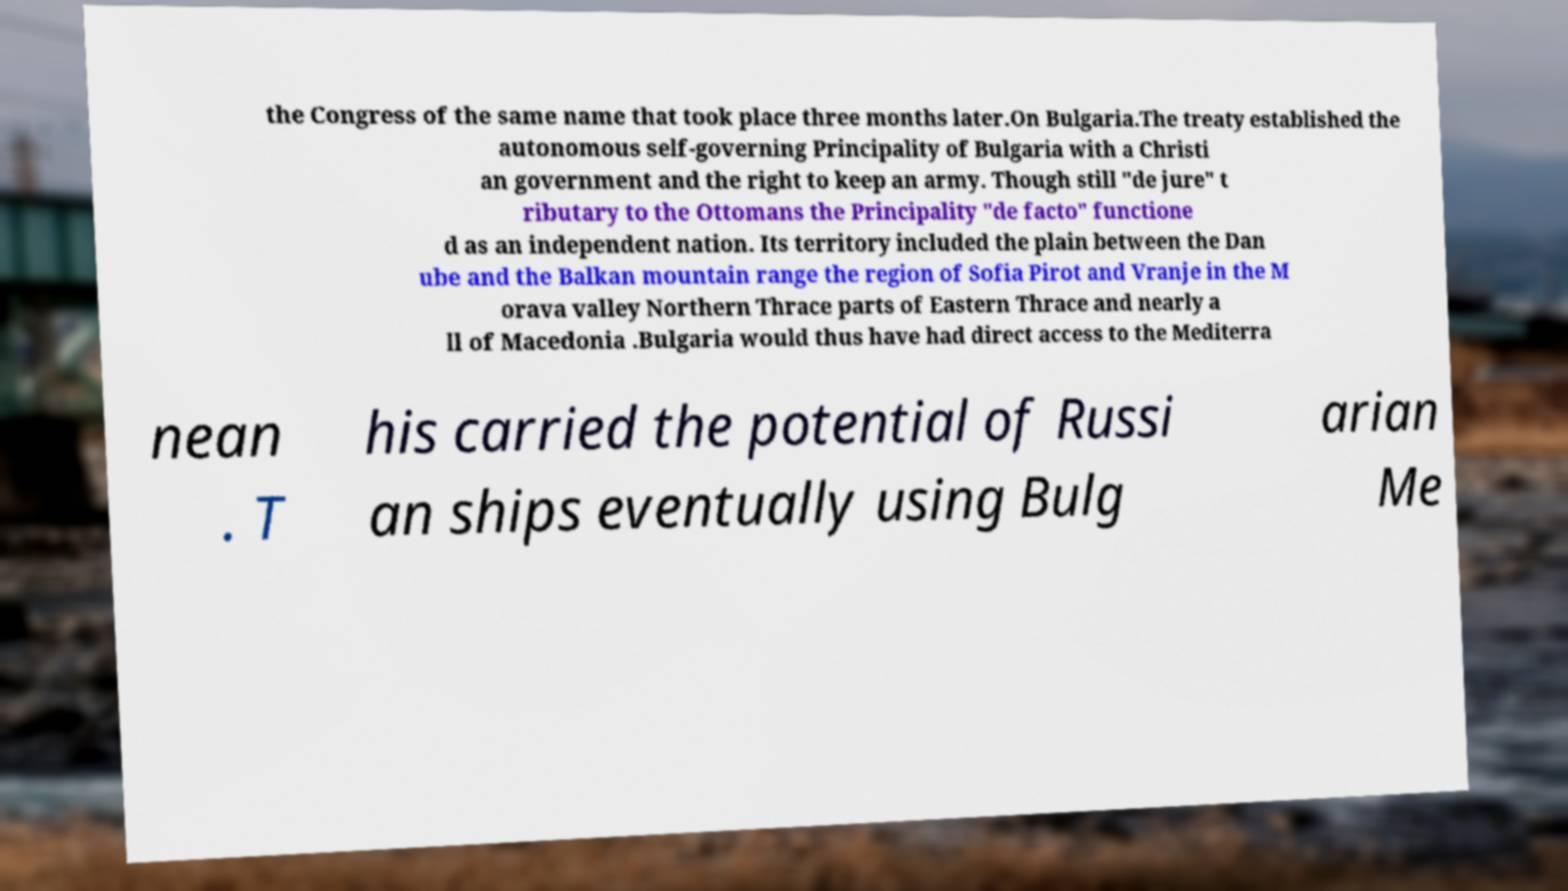I need the written content from this picture converted into text. Can you do that? the Congress of the same name that took place three months later.On Bulgaria.The treaty established the autonomous self-governing Principality of Bulgaria with a Christi an government and the right to keep an army. Though still "de jure" t ributary to the Ottomans the Principality "de facto" functione d as an independent nation. Its territory included the plain between the Dan ube and the Balkan mountain range the region of Sofia Pirot and Vranje in the M orava valley Northern Thrace parts of Eastern Thrace and nearly a ll of Macedonia .Bulgaria would thus have had direct access to the Mediterra nean . T his carried the potential of Russi an ships eventually using Bulg arian Me 